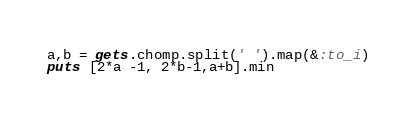<code> <loc_0><loc_0><loc_500><loc_500><_Ruby_>a,b = gets.chomp.split(' ').map(&:to_i)
puts [2*a -1, 2*b-1,a+b].min</code> 